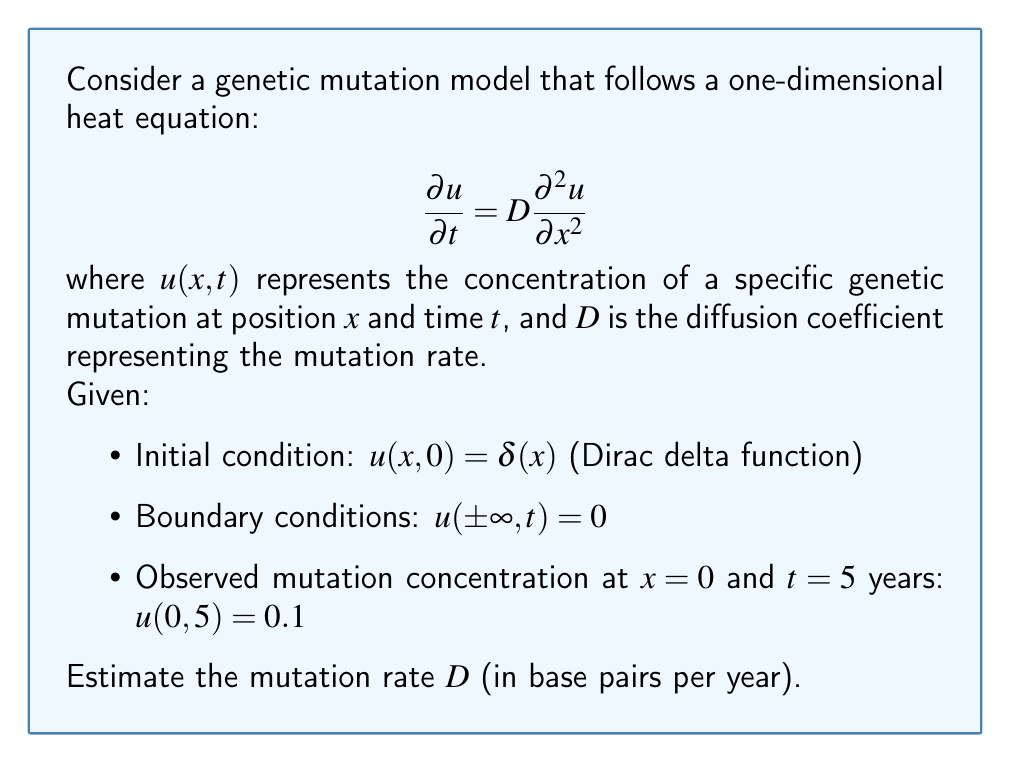Show me your answer to this math problem. To solve this problem, we'll follow these steps:

1) The solution to the heat equation with the given initial and boundary conditions is:

   $$u(x,t) = \frac{1}{\sqrt{4\pi Dt}} e^{-\frac{x^2}{4Dt}}$$

2) We're given that at $x=0$ and $t=5$, $u(0,5) = 0.1$. Let's substitute these values:

   $$0.1 = \frac{1}{\sqrt{4\pi D(5)}}$$

3) Square both sides:

   $$0.01 = \frac{1}{4\pi D(5)}$$

4) Multiply both sides by $4\pi D(5)$:

   $$0.01 \cdot 4\pi D(5) = 1$$

5) Solve for $D$:

   $$D = \frac{1}{0.01 \cdot 4\pi \cdot 5} = \frac{1}{0.2\pi} \approx 1.59$$

6) Therefore, the estimated mutation rate is approximately 1.59 base pairs per year.

This approach uses the fundamental solution of the heat equation and the given data point to estimate the diffusion coefficient, which represents the mutation rate in this context.
Answer: $D \approx 1.59$ base pairs/year 